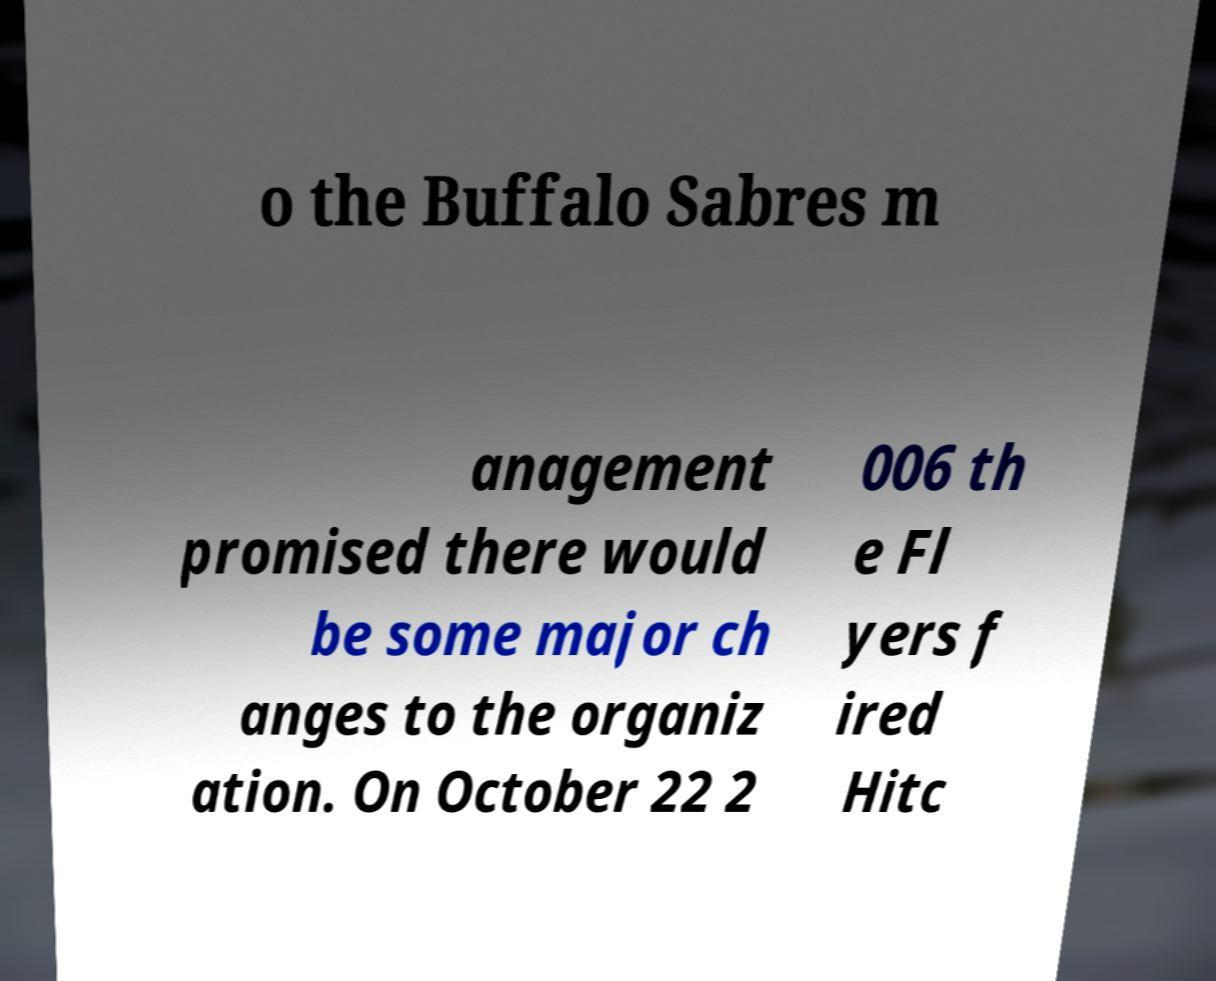I need the written content from this picture converted into text. Can you do that? o the Buffalo Sabres m anagement promised there would be some major ch anges to the organiz ation. On October 22 2 006 th e Fl yers f ired Hitc 